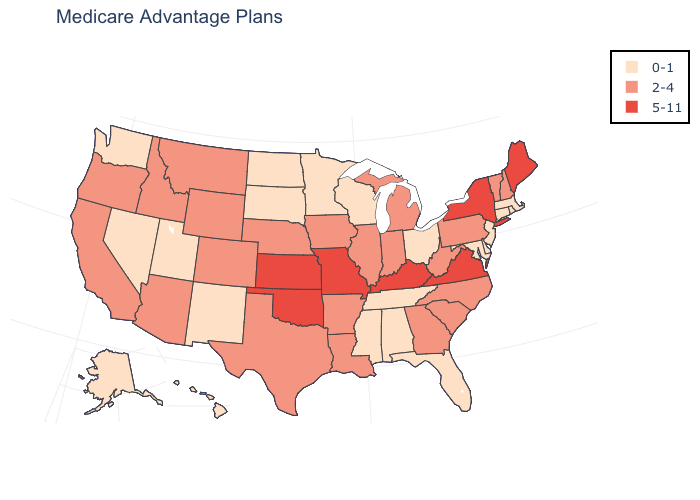What is the lowest value in states that border Montana?
Short answer required. 0-1. What is the value of New York?
Answer briefly. 5-11. Does the first symbol in the legend represent the smallest category?
Be succinct. Yes. Which states have the lowest value in the South?
Answer briefly. Alabama, Delaware, Florida, Maryland, Mississippi, Tennessee. Name the states that have a value in the range 5-11?
Answer briefly. Kansas, Kentucky, Maine, Missouri, New York, Oklahoma, Virginia. What is the value of Minnesota?
Quick response, please. 0-1. Which states have the lowest value in the USA?
Be succinct. Alaska, Alabama, Connecticut, Delaware, Florida, Hawaii, Massachusetts, Maryland, Minnesota, Mississippi, North Dakota, New Jersey, New Mexico, Nevada, Ohio, Rhode Island, South Dakota, Tennessee, Utah, Washington, Wisconsin. Name the states that have a value in the range 2-4?
Keep it brief. Arkansas, Arizona, California, Colorado, Georgia, Iowa, Idaho, Illinois, Indiana, Louisiana, Michigan, Montana, North Carolina, Nebraska, New Hampshire, Oregon, Pennsylvania, South Carolina, Texas, Vermont, West Virginia, Wyoming. Does Georgia have the lowest value in the USA?
Give a very brief answer. No. Does Wisconsin have the same value as New York?
Write a very short answer. No. Name the states that have a value in the range 0-1?
Write a very short answer. Alaska, Alabama, Connecticut, Delaware, Florida, Hawaii, Massachusetts, Maryland, Minnesota, Mississippi, North Dakota, New Jersey, New Mexico, Nevada, Ohio, Rhode Island, South Dakota, Tennessee, Utah, Washington, Wisconsin. Among the states that border North Dakota , which have the highest value?
Quick response, please. Montana. What is the highest value in the South ?
Write a very short answer. 5-11. What is the value of New Hampshire?
Write a very short answer. 2-4. Which states have the highest value in the USA?
Concise answer only. Kansas, Kentucky, Maine, Missouri, New York, Oklahoma, Virginia. 